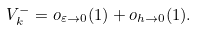Convert formula to latex. <formula><loc_0><loc_0><loc_500><loc_500>V _ { k } ^ { - } = o _ { \varepsilon \to 0 } ( 1 ) + o _ { h \to 0 } ( 1 ) .</formula> 